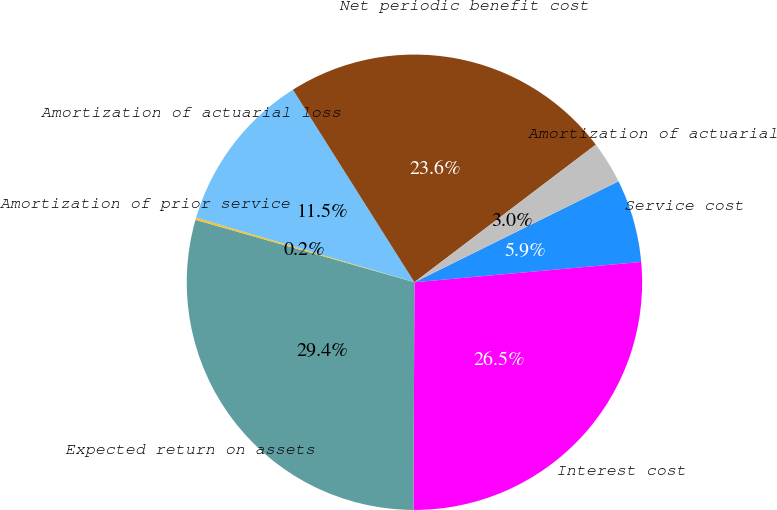Convert chart to OTSL. <chart><loc_0><loc_0><loc_500><loc_500><pie_chart><fcel>Service cost<fcel>Interest cost<fcel>Expected return on assets<fcel>Amortization of prior service<fcel>Amortization of actuarial loss<fcel>Net periodic benefit cost<fcel>Amortization of actuarial<nl><fcel>5.89%<fcel>26.49%<fcel>29.35%<fcel>0.16%<fcel>11.46%<fcel>23.63%<fcel>3.02%<nl></chart> 